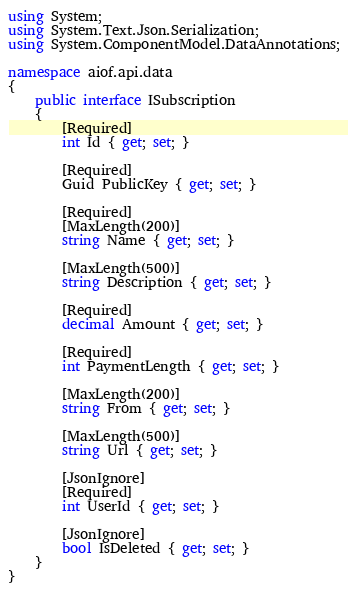Convert code to text. <code><loc_0><loc_0><loc_500><loc_500><_C#_>using System;
using System.Text.Json.Serialization;
using System.ComponentModel.DataAnnotations;

namespace aiof.api.data
{
    public interface ISubscription
    {
        [Required]
        int Id { get; set; }

        [Required]
        Guid PublicKey { get; set; }

        [Required]
        [MaxLength(200)]
        string Name { get; set; }

        [MaxLength(500)]
        string Description { get; set; }

        [Required]
        decimal Amount { get; set; }
        
        [Required]
        int PaymentLength { get; set; }

        [MaxLength(200)]
        string From { get; set; }

        [MaxLength(500)]
        string Url { get; set; }

        [JsonIgnore]
        [Required]
        int UserId { get; set; }

        [JsonIgnore]
        bool IsDeleted { get; set; }
    }
}</code> 